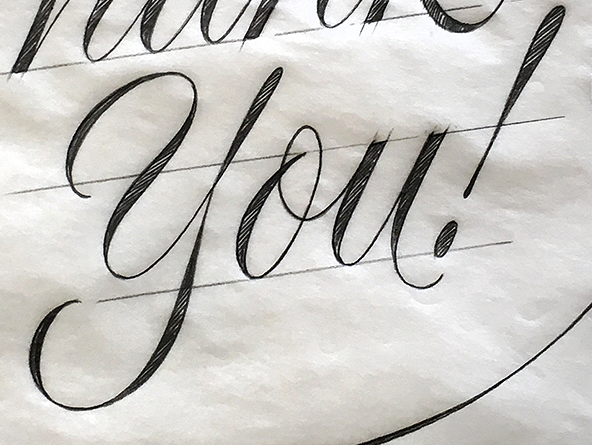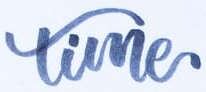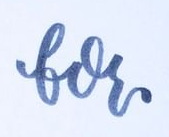Read the text content from these images in order, separated by a semicolon. you!; time; for 